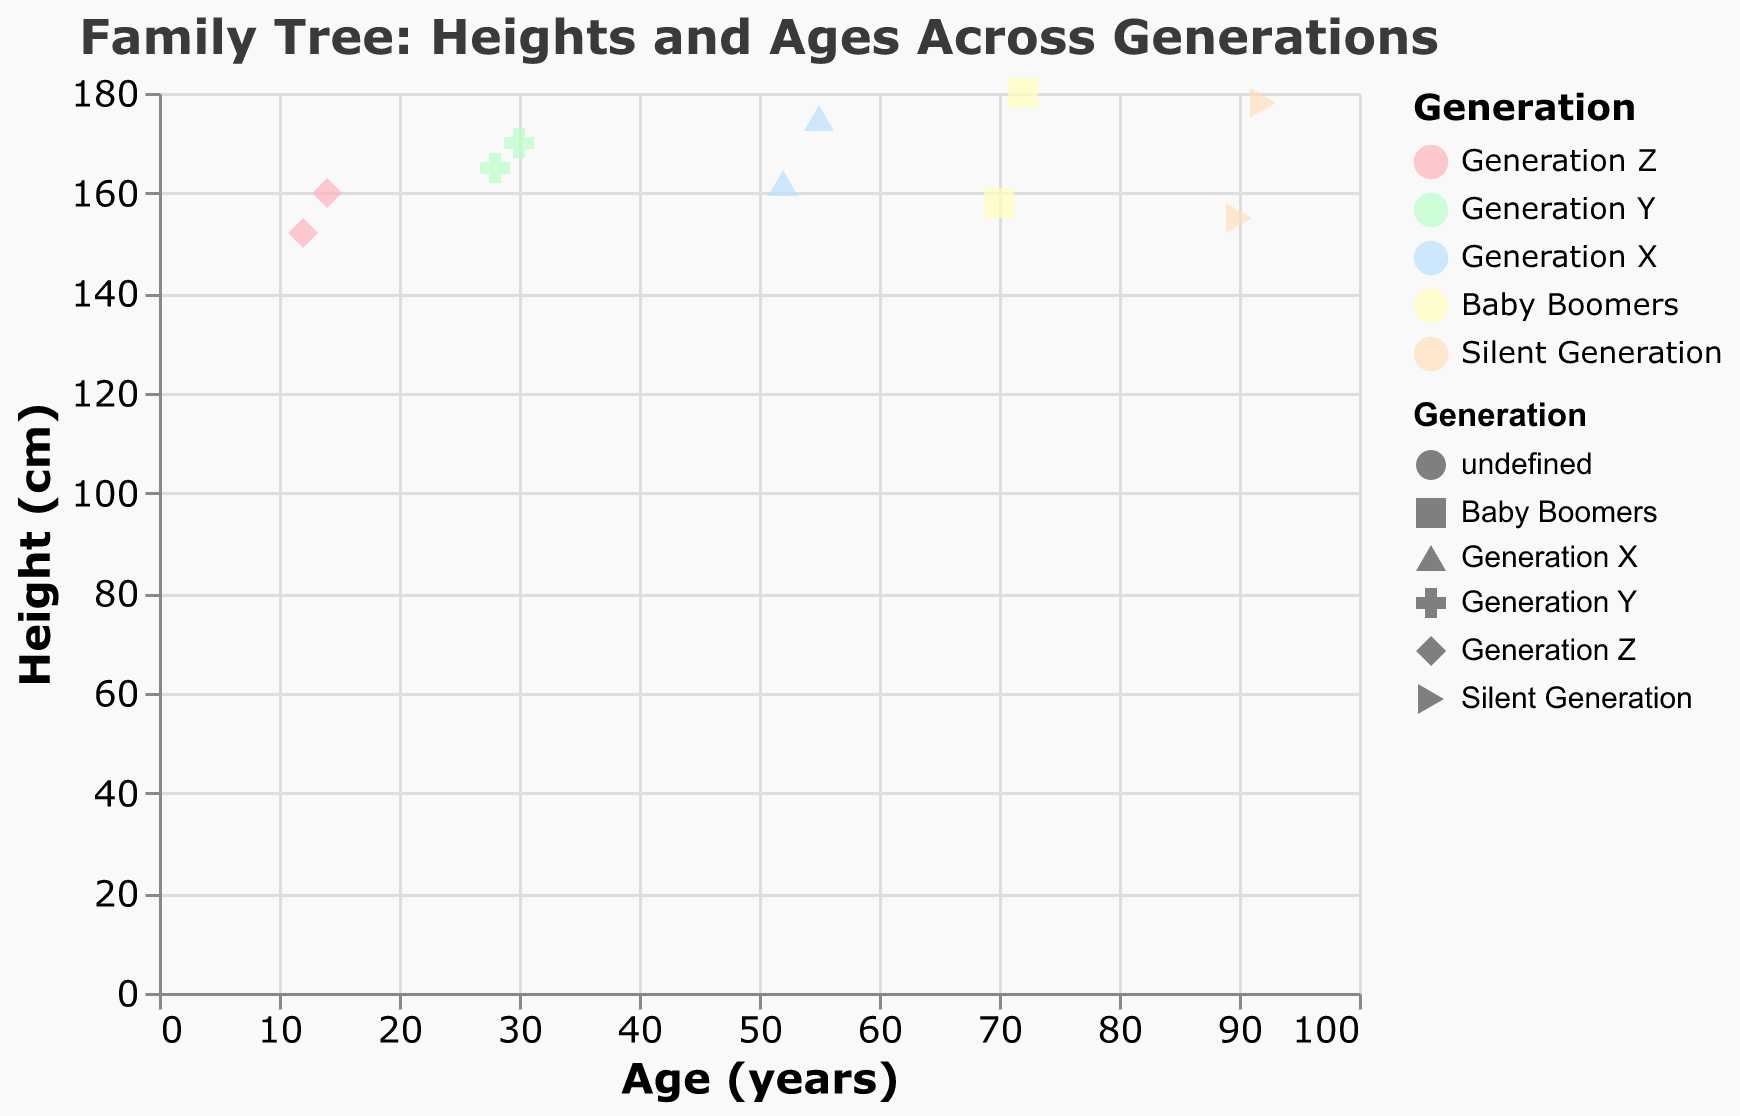What is the title of the scatter plot? The title of the plot is usually found at the top-center of the figure. In this case, the title reads "Family Tree: Heights and Ages Across Generations".
Answer: Family Tree: Heights and Ages Across Generations How many generations are represented in the scatter plot? By looking at the color legend, we can see the names of the generations depicted in the plot. The generations listed are "Generation Z", "Generation Y", "Generation X", "Baby Boomers", and "Silent Generation".
Answer: 5 Which generation has the tallest individual? To determine this, we need to find the color and shape representing each generation and then locate the highest point on the y-axis. The tallest height on the y-axis is 180 cm, represented by a data point from Noah in "Baby Boomers".
Answer: Baby Boomers What is the trend line trying to show? A trend line on a scatter plot shows the overall direction or pattern of the data. In this case, it illustrates the general relationship between heights and ages across the different generations of the family.
Answer: Relationship between heights and ages Is there more variation in height within the same generation or across different generations? By examining the spread of data points within each color (generation), we observe that variation in height exists within each generation. However, a broader range is observed across different generations, indicated by the diversity in color along the y-axis (height).
Answer: Across different generations Which generation has the most significant age gap between its members? To find this, we compare the age ranges within each generation. The "Silent Generation" has ages ranging from 90 to 92, "Baby Boomers" from 70 to 72, "Generation X" from 52 to 55, "Generation Y" from 28 to 30, and "Generation Z" from 12 to 14. The "Silent Generation" has the largest gap (2 years).
Answer: Silent Generation What is the average height of Generation Y members? To find the average height of Generation Y members, we add the heights of Sophia (165 cm) and Liam (170 cm) and divide by the number of members (2). (165 + 170) / 2 = 167.5 cm.
Answer: 167.5 cm Which individual has the lowest height, and what is their generation? The individual with the lowest height can be identified by finding the lowest point along the y-axis. Emily, from "Generation Z", is the shortest at 152 cm.
Answer: Emily, Generation Z How does height generally change across generations according to the trend line? According to the trend line, height generally increases as we move from older to younger generations. This suggests a positive correlation where the trend line slightly ascends from left (older ages) to right (younger ages).
Answer: Increases 